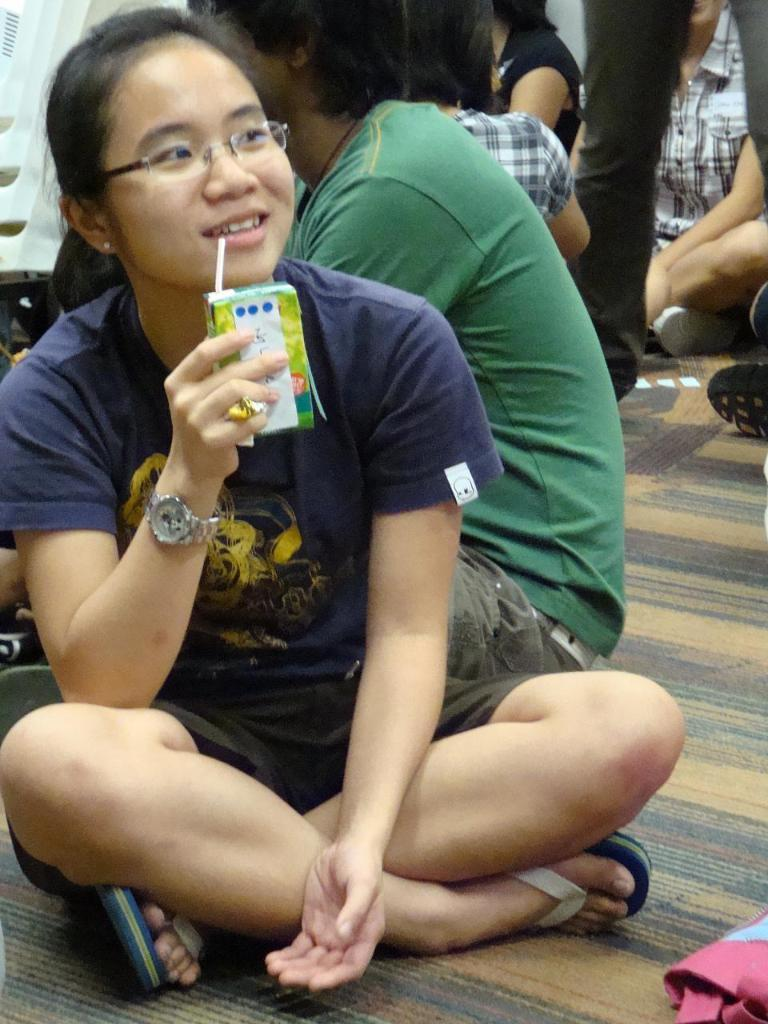What are the people in the image doing? The people in the image are sitting on the floor. What can be seen in the bottom right corner of the image? There is an object at the bottom right corner of the image. Can you describe the person standing in the image? There is a person standing at the right side of the image. What type of club is the person holding in the image? There is no club present in the image; the people are sitting on the floor and there is a person standing, but no club is visible. 